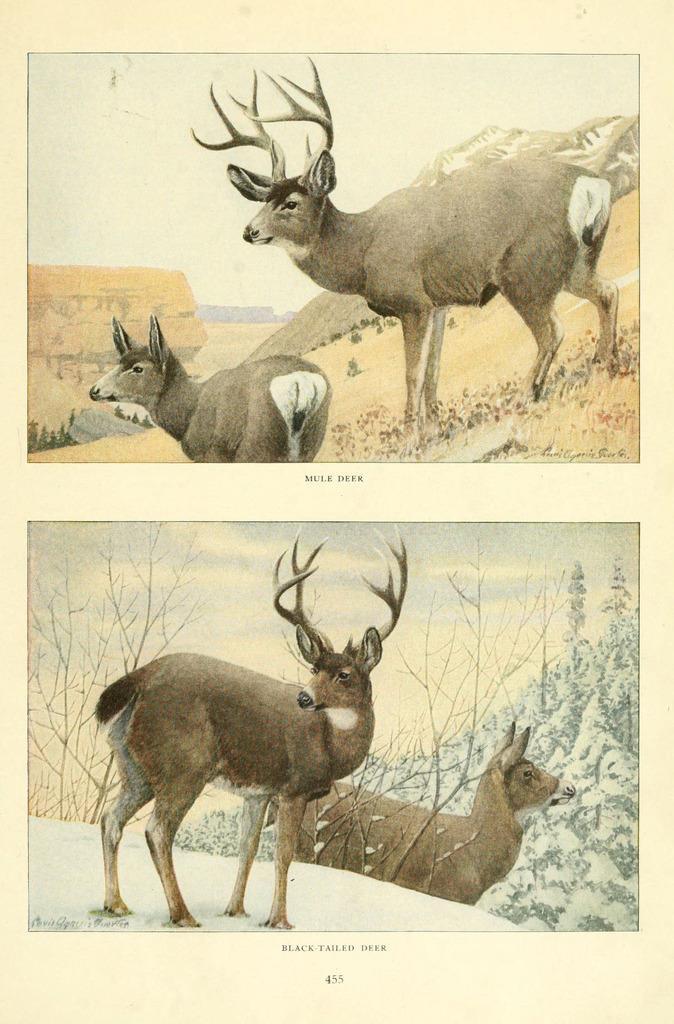Describe this image in one or two sentences. This is a collage image of animals, trees, mountains, snow and the sky, below the image there is some text. 